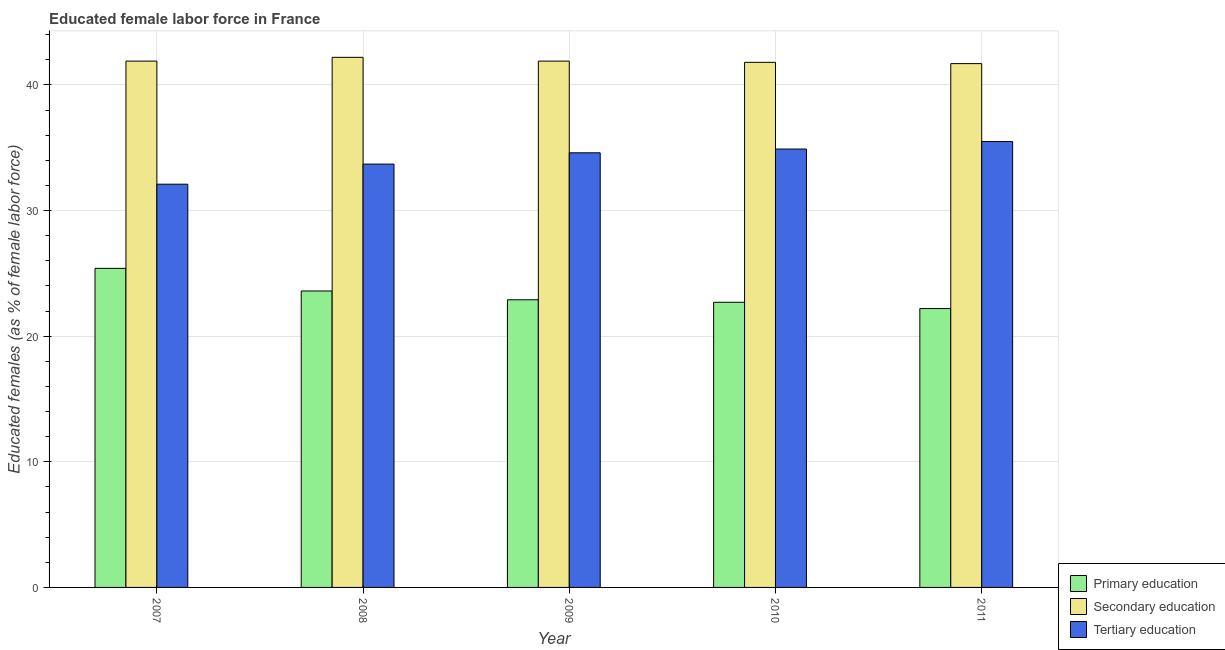How many groups of bars are there?
Make the answer very short. 5. Are the number of bars on each tick of the X-axis equal?
Ensure brevity in your answer.  Yes. How many bars are there on the 3rd tick from the left?
Your answer should be compact. 3. How many bars are there on the 5th tick from the right?
Your answer should be very brief. 3. In how many cases, is the number of bars for a given year not equal to the number of legend labels?
Your response must be concise. 0. What is the percentage of female labor force who received primary education in 2007?
Offer a terse response. 25.4. Across all years, what is the maximum percentage of female labor force who received tertiary education?
Ensure brevity in your answer.  35.5. Across all years, what is the minimum percentage of female labor force who received primary education?
Ensure brevity in your answer.  22.2. In which year was the percentage of female labor force who received secondary education maximum?
Your answer should be compact. 2008. What is the total percentage of female labor force who received secondary education in the graph?
Provide a succinct answer. 209.5. What is the difference between the percentage of female labor force who received primary education in 2009 and that in 2010?
Offer a terse response. 0.2. What is the difference between the percentage of female labor force who received primary education in 2007 and the percentage of female labor force who received secondary education in 2008?
Provide a short and direct response. 1.8. What is the average percentage of female labor force who received tertiary education per year?
Ensure brevity in your answer.  34.16. In how many years, is the percentage of female labor force who received primary education greater than 20 %?
Keep it short and to the point. 5. What is the ratio of the percentage of female labor force who received tertiary education in 2007 to that in 2008?
Ensure brevity in your answer.  0.95. Is the percentage of female labor force who received secondary education in 2008 less than that in 2009?
Provide a succinct answer. No. Is the difference between the percentage of female labor force who received secondary education in 2007 and 2008 greater than the difference between the percentage of female labor force who received tertiary education in 2007 and 2008?
Provide a short and direct response. No. What is the difference between the highest and the second highest percentage of female labor force who received secondary education?
Make the answer very short. 0.3. What is the difference between the highest and the lowest percentage of female labor force who received tertiary education?
Your response must be concise. 3.4. In how many years, is the percentage of female labor force who received primary education greater than the average percentage of female labor force who received primary education taken over all years?
Provide a succinct answer. 2. What does the 1st bar from the right in 2007 represents?
Provide a short and direct response. Tertiary education. Is it the case that in every year, the sum of the percentage of female labor force who received primary education and percentage of female labor force who received secondary education is greater than the percentage of female labor force who received tertiary education?
Keep it short and to the point. Yes. How many years are there in the graph?
Keep it short and to the point. 5. What is the difference between two consecutive major ticks on the Y-axis?
Provide a short and direct response. 10. Does the graph contain any zero values?
Keep it short and to the point. No. How are the legend labels stacked?
Your answer should be very brief. Vertical. What is the title of the graph?
Provide a short and direct response. Educated female labor force in France. What is the label or title of the X-axis?
Offer a very short reply. Year. What is the label or title of the Y-axis?
Your answer should be compact. Educated females (as % of female labor force). What is the Educated females (as % of female labor force) in Primary education in 2007?
Offer a terse response. 25.4. What is the Educated females (as % of female labor force) in Secondary education in 2007?
Give a very brief answer. 41.9. What is the Educated females (as % of female labor force) in Tertiary education in 2007?
Offer a very short reply. 32.1. What is the Educated females (as % of female labor force) in Primary education in 2008?
Ensure brevity in your answer.  23.6. What is the Educated females (as % of female labor force) in Secondary education in 2008?
Give a very brief answer. 42.2. What is the Educated females (as % of female labor force) of Tertiary education in 2008?
Your response must be concise. 33.7. What is the Educated females (as % of female labor force) in Primary education in 2009?
Make the answer very short. 22.9. What is the Educated females (as % of female labor force) of Secondary education in 2009?
Keep it short and to the point. 41.9. What is the Educated females (as % of female labor force) of Tertiary education in 2009?
Offer a very short reply. 34.6. What is the Educated females (as % of female labor force) in Primary education in 2010?
Make the answer very short. 22.7. What is the Educated females (as % of female labor force) in Secondary education in 2010?
Offer a terse response. 41.8. What is the Educated females (as % of female labor force) in Tertiary education in 2010?
Your answer should be very brief. 34.9. What is the Educated females (as % of female labor force) of Primary education in 2011?
Make the answer very short. 22.2. What is the Educated females (as % of female labor force) in Secondary education in 2011?
Your response must be concise. 41.7. What is the Educated females (as % of female labor force) of Tertiary education in 2011?
Your response must be concise. 35.5. Across all years, what is the maximum Educated females (as % of female labor force) in Primary education?
Keep it short and to the point. 25.4. Across all years, what is the maximum Educated females (as % of female labor force) in Secondary education?
Keep it short and to the point. 42.2. Across all years, what is the maximum Educated females (as % of female labor force) of Tertiary education?
Offer a very short reply. 35.5. Across all years, what is the minimum Educated females (as % of female labor force) of Primary education?
Offer a terse response. 22.2. Across all years, what is the minimum Educated females (as % of female labor force) in Secondary education?
Ensure brevity in your answer.  41.7. Across all years, what is the minimum Educated females (as % of female labor force) of Tertiary education?
Your response must be concise. 32.1. What is the total Educated females (as % of female labor force) of Primary education in the graph?
Offer a very short reply. 116.8. What is the total Educated females (as % of female labor force) of Secondary education in the graph?
Make the answer very short. 209.5. What is the total Educated females (as % of female labor force) of Tertiary education in the graph?
Keep it short and to the point. 170.8. What is the difference between the Educated females (as % of female labor force) of Secondary education in 2007 and that in 2008?
Your response must be concise. -0.3. What is the difference between the Educated females (as % of female labor force) in Primary education in 2007 and that in 2009?
Make the answer very short. 2.5. What is the difference between the Educated females (as % of female labor force) of Secondary education in 2007 and that in 2009?
Keep it short and to the point. 0. What is the difference between the Educated females (as % of female labor force) of Tertiary education in 2007 and that in 2009?
Ensure brevity in your answer.  -2.5. What is the difference between the Educated females (as % of female labor force) of Secondary education in 2007 and that in 2010?
Make the answer very short. 0.1. What is the difference between the Educated females (as % of female labor force) in Secondary education in 2007 and that in 2011?
Offer a very short reply. 0.2. What is the difference between the Educated females (as % of female labor force) in Tertiary education in 2007 and that in 2011?
Make the answer very short. -3.4. What is the difference between the Educated females (as % of female labor force) of Secondary education in 2008 and that in 2010?
Offer a terse response. 0.4. What is the difference between the Educated females (as % of female labor force) in Secondary education in 2008 and that in 2011?
Keep it short and to the point. 0.5. What is the difference between the Educated females (as % of female labor force) of Tertiary education in 2008 and that in 2011?
Provide a short and direct response. -1.8. What is the difference between the Educated females (as % of female labor force) of Primary education in 2009 and that in 2010?
Your answer should be compact. 0.2. What is the difference between the Educated females (as % of female labor force) in Secondary education in 2009 and that in 2011?
Ensure brevity in your answer.  0.2. What is the difference between the Educated females (as % of female labor force) in Tertiary education in 2009 and that in 2011?
Keep it short and to the point. -0.9. What is the difference between the Educated females (as % of female labor force) in Primary education in 2010 and that in 2011?
Give a very brief answer. 0.5. What is the difference between the Educated females (as % of female labor force) in Tertiary education in 2010 and that in 2011?
Provide a short and direct response. -0.6. What is the difference between the Educated females (as % of female labor force) in Primary education in 2007 and the Educated females (as % of female labor force) in Secondary education in 2008?
Ensure brevity in your answer.  -16.8. What is the difference between the Educated females (as % of female labor force) in Secondary education in 2007 and the Educated females (as % of female labor force) in Tertiary education in 2008?
Make the answer very short. 8.2. What is the difference between the Educated females (as % of female labor force) in Primary education in 2007 and the Educated females (as % of female labor force) in Secondary education in 2009?
Ensure brevity in your answer.  -16.5. What is the difference between the Educated females (as % of female labor force) of Secondary education in 2007 and the Educated females (as % of female labor force) of Tertiary education in 2009?
Provide a succinct answer. 7.3. What is the difference between the Educated females (as % of female labor force) in Primary education in 2007 and the Educated females (as % of female labor force) in Secondary education in 2010?
Make the answer very short. -16.4. What is the difference between the Educated females (as % of female labor force) in Primary education in 2007 and the Educated females (as % of female labor force) in Secondary education in 2011?
Your response must be concise. -16.3. What is the difference between the Educated females (as % of female labor force) of Primary education in 2007 and the Educated females (as % of female labor force) of Tertiary education in 2011?
Offer a terse response. -10.1. What is the difference between the Educated females (as % of female labor force) in Primary education in 2008 and the Educated females (as % of female labor force) in Secondary education in 2009?
Your answer should be compact. -18.3. What is the difference between the Educated females (as % of female labor force) of Secondary education in 2008 and the Educated females (as % of female labor force) of Tertiary education in 2009?
Offer a very short reply. 7.6. What is the difference between the Educated females (as % of female labor force) of Primary education in 2008 and the Educated females (as % of female labor force) of Secondary education in 2010?
Your answer should be very brief. -18.2. What is the difference between the Educated females (as % of female labor force) of Primary education in 2008 and the Educated females (as % of female labor force) of Secondary education in 2011?
Your response must be concise. -18.1. What is the difference between the Educated females (as % of female labor force) of Primary education in 2008 and the Educated females (as % of female labor force) of Tertiary education in 2011?
Keep it short and to the point. -11.9. What is the difference between the Educated females (as % of female labor force) in Primary education in 2009 and the Educated females (as % of female labor force) in Secondary education in 2010?
Provide a short and direct response. -18.9. What is the difference between the Educated females (as % of female labor force) of Primary education in 2009 and the Educated females (as % of female labor force) of Secondary education in 2011?
Provide a succinct answer. -18.8. What is the difference between the Educated females (as % of female labor force) in Secondary education in 2009 and the Educated females (as % of female labor force) in Tertiary education in 2011?
Your answer should be compact. 6.4. What is the difference between the Educated females (as % of female labor force) in Secondary education in 2010 and the Educated females (as % of female labor force) in Tertiary education in 2011?
Keep it short and to the point. 6.3. What is the average Educated females (as % of female labor force) in Primary education per year?
Ensure brevity in your answer.  23.36. What is the average Educated females (as % of female labor force) of Secondary education per year?
Your answer should be compact. 41.9. What is the average Educated females (as % of female labor force) of Tertiary education per year?
Your answer should be very brief. 34.16. In the year 2007, what is the difference between the Educated females (as % of female labor force) of Primary education and Educated females (as % of female labor force) of Secondary education?
Provide a short and direct response. -16.5. In the year 2007, what is the difference between the Educated females (as % of female labor force) in Secondary education and Educated females (as % of female labor force) in Tertiary education?
Give a very brief answer. 9.8. In the year 2008, what is the difference between the Educated females (as % of female labor force) in Primary education and Educated females (as % of female labor force) in Secondary education?
Provide a succinct answer. -18.6. In the year 2008, what is the difference between the Educated females (as % of female labor force) in Primary education and Educated females (as % of female labor force) in Tertiary education?
Your response must be concise. -10.1. In the year 2008, what is the difference between the Educated females (as % of female labor force) in Secondary education and Educated females (as % of female labor force) in Tertiary education?
Provide a succinct answer. 8.5. In the year 2009, what is the difference between the Educated females (as % of female labor force) in Primary education and Educated females (as % of female labor force) in Secondary education?
Make the answer very short. -19. In the year 2009, what is the difference between the Educated females (as % of female labor force) in Primary education and Educated females (as % of female labor force) in Tertiary education?
Your answer should be compact. -11.7. In the year 2009, what is the difference between the Educated females (as % of female labor force) in Secondary education and Educated females (as % of female labor force) in Tertiary education?
Provide a short and direct response. 7.3. In the year 2010, what is the difference between the Educated females (as % of female labor force) in Primary education and Educated females (as % of female labor force) in Secondary education?
Keep it short and to the point. -19.1. In the year 2010, what is the difference between the Educated females (as % of female labor force) of Secondary education and Educated females (as % of female labor force) of Tertiary education?
Your answer should be very brief. 6.9. In the year 2011, what is the difference between the Educated females (as % of female labor force) in Primary education and Educated females (as % of female labor force) in Secondary education?
Keep it short and to the point. -19.5. In the year 2011, what is the difference between the Educated females (as % of female labor force) in Primary education and Educated females (as % of female labor force) in Tertiary education?
Your response must be concise. -13.3. In the year 2011, what is the difference between the Educated females (as % of female labor force) of Secondary education and Educated females (as % of female labor force) of Tertiary education?
Offer a very short reply. 6.2. What is the ratio of the Educated females (as % of female labor force) in Primary education in 2007 to that in 2008?
Offer a terse response. 1.08. What is the ratio of the Educated females (as % of female labor force) of Tertiary education in 2007 to that in 2008?
Ensure brevity in your answer.  0.95. What is the ratio of the Educated females (as % of female labor force) in Primary education in 2007 to that in 2009?
Your answer should be compact. 1.11. What is the ratio of the Educated females (as % of female labor force) in Secondary education in 2007 to that in 2009?
Your answer should be compact. 1. What is the ratio of the Educated females (as % of female labor force) of Tertiary education in 2007 to that in 2009?
Your response must be concise. 0.93. What is the ratio of the Educated females (as % of female labor force) in Primary education in 2007 to that in 2010?
Your response must be concise. 1.12. What is the ratio of the Educated females (as % of female labor force) of Secondary education in 2007 to that in 2010?
Your answer should be very brief. 1. What is the ratio of the Educated females (as % of female labor force) in Tertiary education in 2007 to that in 2010?
Offer a terse response. 0.92. What is the ratio of the Educated females (as % of female labor force) of Primary education in 2007 to that in 2011?
Your answer should be compact. 1.14. What is the ratio of the Educated females (as % of female labor force) of Tertiary education in 2007 to that in 2011?
Your answer should be very brief. 0.9. What is the ratio of the Educated females (as % of female labor force) of Primary education in 2008 to that in 2009?
Make the answer very short. 1.03. What is the ratio of the Educated females (as % of female labor force) of Secondary education in 2008 to that in 2009?
Offer a very short reply. 1.01. What is the ratio of the Educated females (as % of female labor force) in Tertiary education in 2008 to that in 2009?
Offer a terse response. 0.97. What is the ratio of the Educated females (as % of female labor force) in Primary education in 2008 to that in 2010?
Your response must be concise. 1.04. What is the ratio of the Educated females (as % of female labor force) in Secondary education in 2008 to that in 2010?
Offer a very short reply. 1.01. What is the ratio of the Educated females (as % of female labor force) in Tertiary education in 2008 to that in 2010?
Your answer should be compact. 0.97. What is the ratio of the Educated females (as % of female labor force) in Primary education in 2008 to that in 2011?
Your answer should be compact. 1.06. What is the ratio of the Educated females (as % of female labor force) of Secondary education in 2008 to that in 2011?
Provide a succinct answer. 1.01. What is the ratio of the Educated females (as % of female labor force) in Tertiary education in 2008 to that in 2011?
Make the answer very short. 0.95. What is the ratio of the Educated females (as % of female labor force) in Primary education in 2009 to that in 2010?
Provide a succinct answer. 1.01. What is the ratio of the Educated females (as % of female labor force) of Secondary education in 2009 to that in 2010?
Keep it short and to the point. 1. What is the ratio of the Educated females (as % of female labor force) in Primary education in 2009 to that in 2011?
Your response must be concise. 1.03. What is the ratio of the Educated females (as % of female labor force) in Secondary education in 2009 to that in 2011?
Your response must be concise. 1. What is the ratio of the Educated females (as % of female labor force) of Tertiary education in 2009 to that in 2011?
Your answer should be very brief. 0.97. What is the ratio of the Educated females (as % of female labor force) in Primary education in 2010 to that in 2011?
Provide a succinct answer. 1.02. What is the ratio of the Educated females (as % of female labor force) in Secondary education in 2010 to that in 2011?
Offer a very short reply. 1. What is the ratio of the Educated females (as % of female labor force) of Tertiary education in 2010 to that in 2011?
Your answer should be compact. 0.98. What is the difference between the highest and the lowest Educated females (as % of female labor force) of Primary education?
Keep it short and to the point. 3.2. What is the difference between the highest and the lowest Educated females (as % of female labor force) in Secondary education?
Provide a succinct answer. 0.5. 